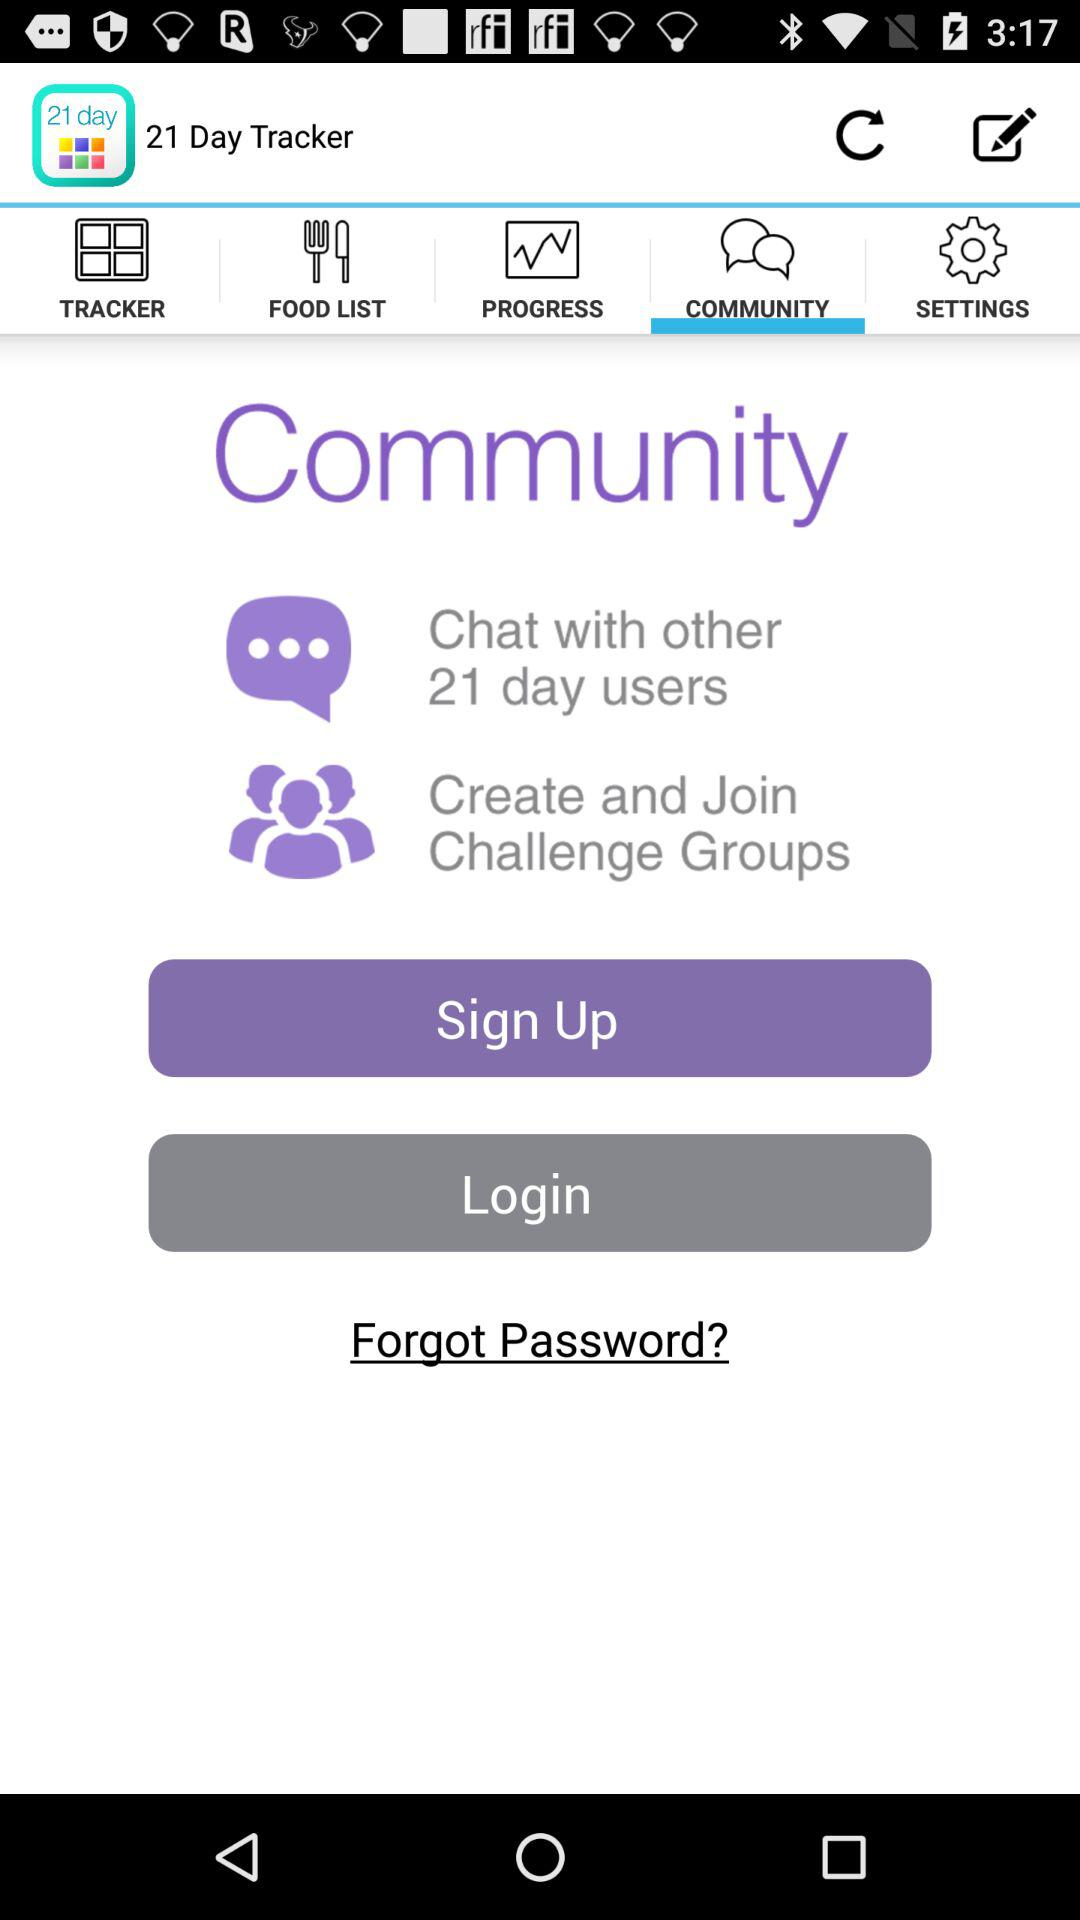With whom can I chat? You can chat with other 21 day users. 